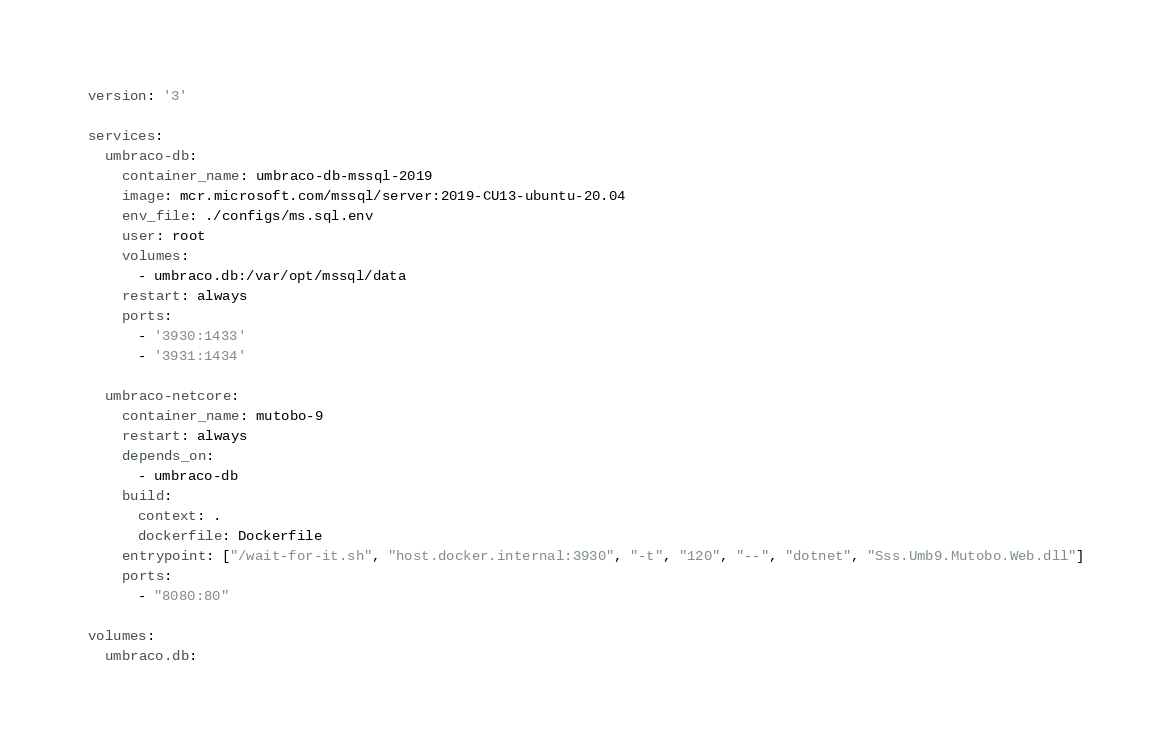<code> <loc_0><loc_0><loc_500><loc_500><_YAML_>version: '3'

services:
  umbraco-db:
    container_name: umbraco-db-mssql-2019
    image: mcr.microsoft.com/mssql/server:2019-CU13-ubuntu-20.04
    env_file: ./configs/ms.sql.env
    user: root
    volumes:
      - umbraco.db:/var/opt/mssql/data
    restart: always
    ports:
      - '3930:1433'
      - '3931:1434'
  
  umbraco-netcore:
    container_name: mutobo-9
    restart: always
    depends_on:
      - umbraco-db
    build:
      context: .
      dockerfile: Dockerfile
    entrypoint: ["/wait-for-it.sh", "host.docker.internal:3930", "-t", "120", "--", "dotnet", "Sss.Umb9.Mutobo.Web.dll"]
    ports:
      - "8080:80"

volumes:
  umbraco.db:</code> 